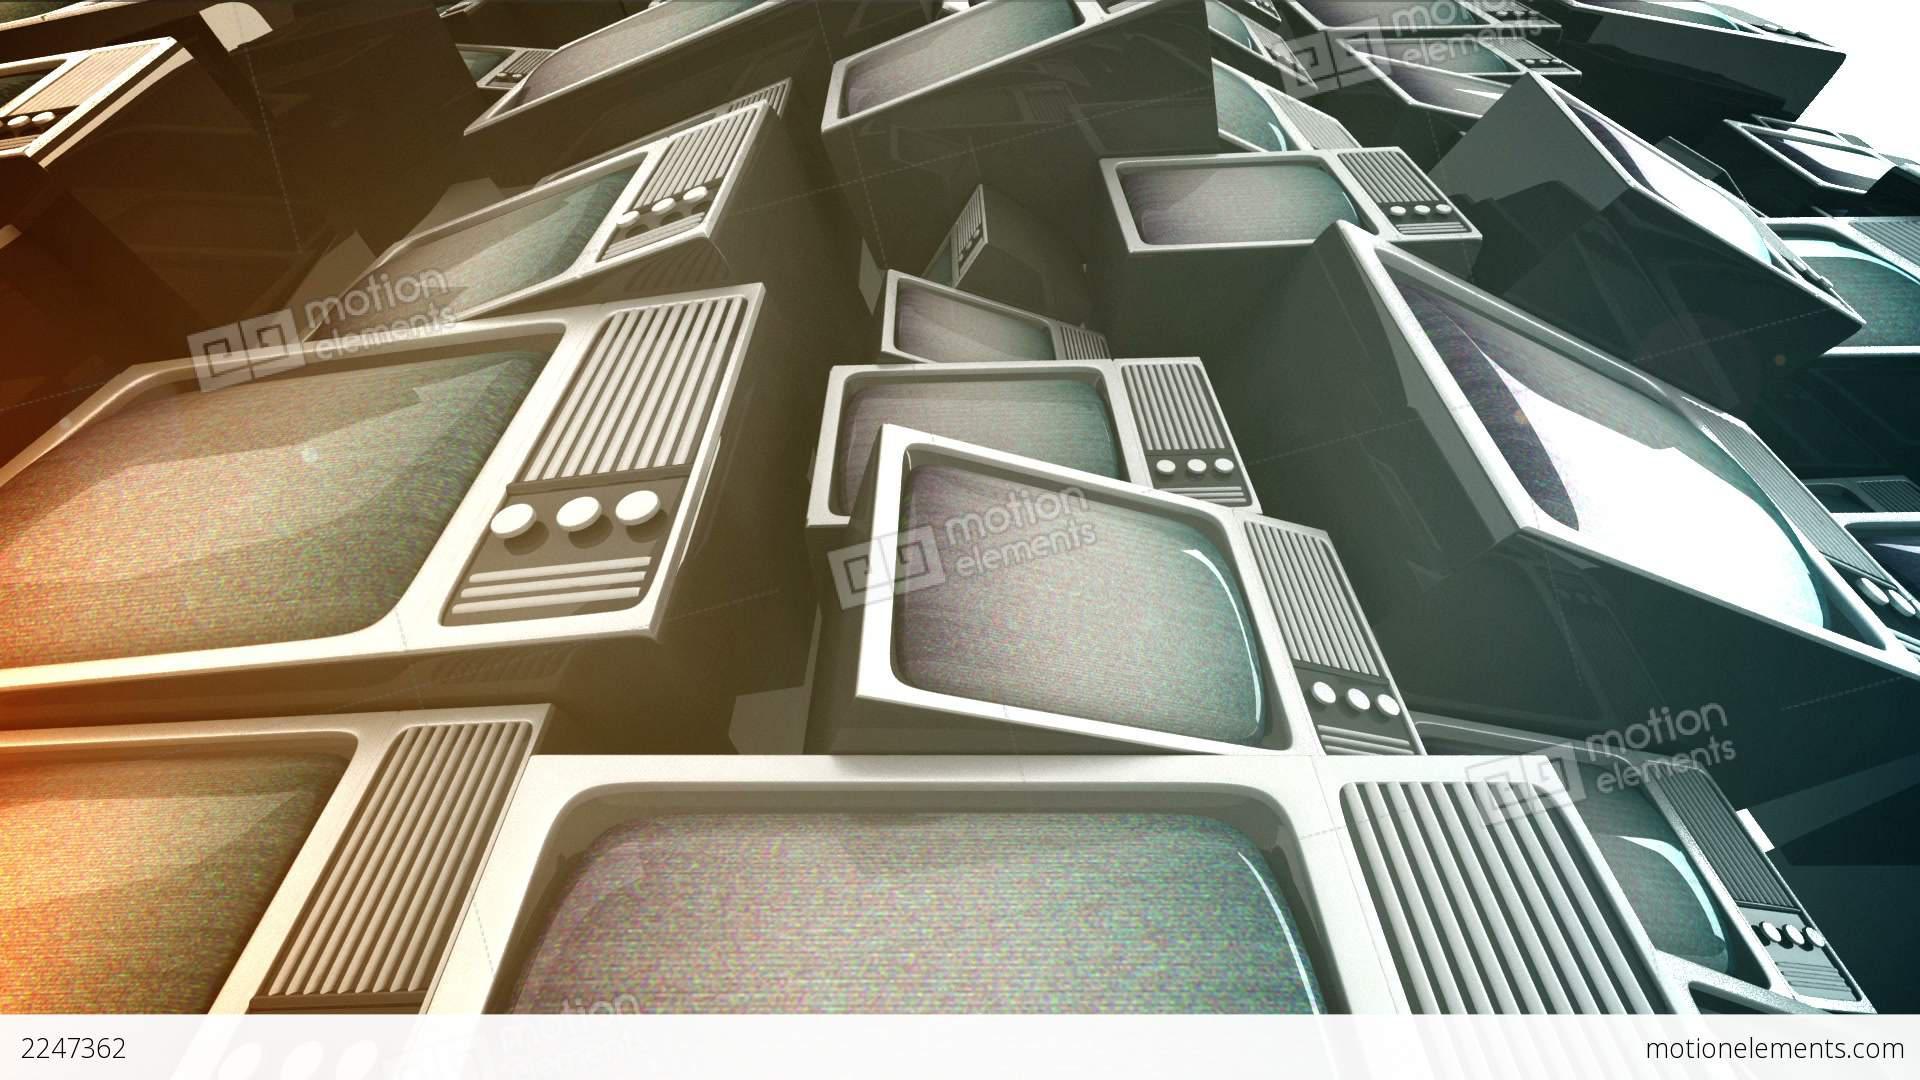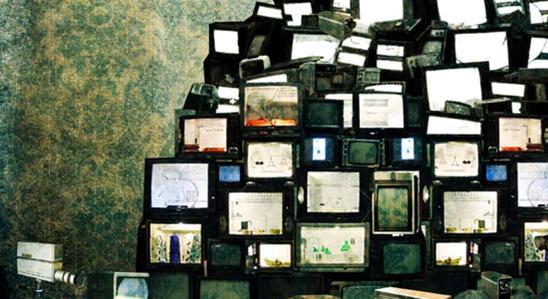The first image is the image on the left, the second image is the image on the right. Given the left and right images, does the statement "All the televisions are off." hold true? Answer yes or no. No. The first image is the image on the left, the second image is the image on the right. Examine the images to the left and right. Is the description "At least one image shows an upward view of 'endless' stacked televisions that feature three round white knobs in a horizontal row right of the screen." accurate? Answer yes or no. Yes. 